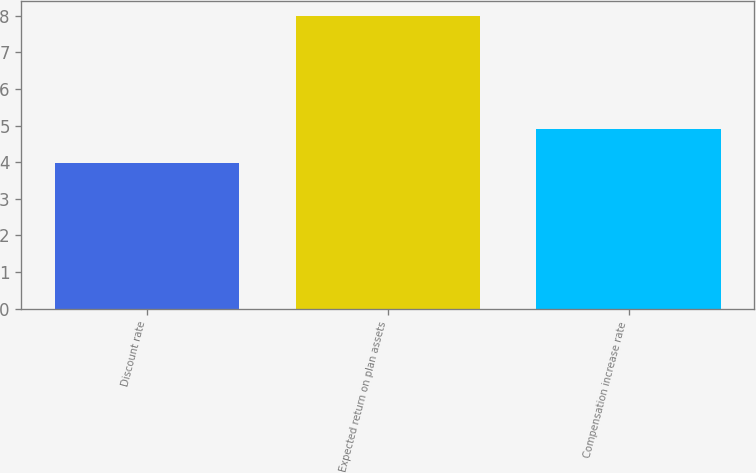Convert chart to OTSL. <chart><loc_0><loc_0><loc_500><loc_500><bar_chart><fcel>Discount rate<fcel>Expected return on plan assets<fcel>Compensation increase rate<nl><fcel>3.97<fcel>8<fcel>4.91<nl></chart> 